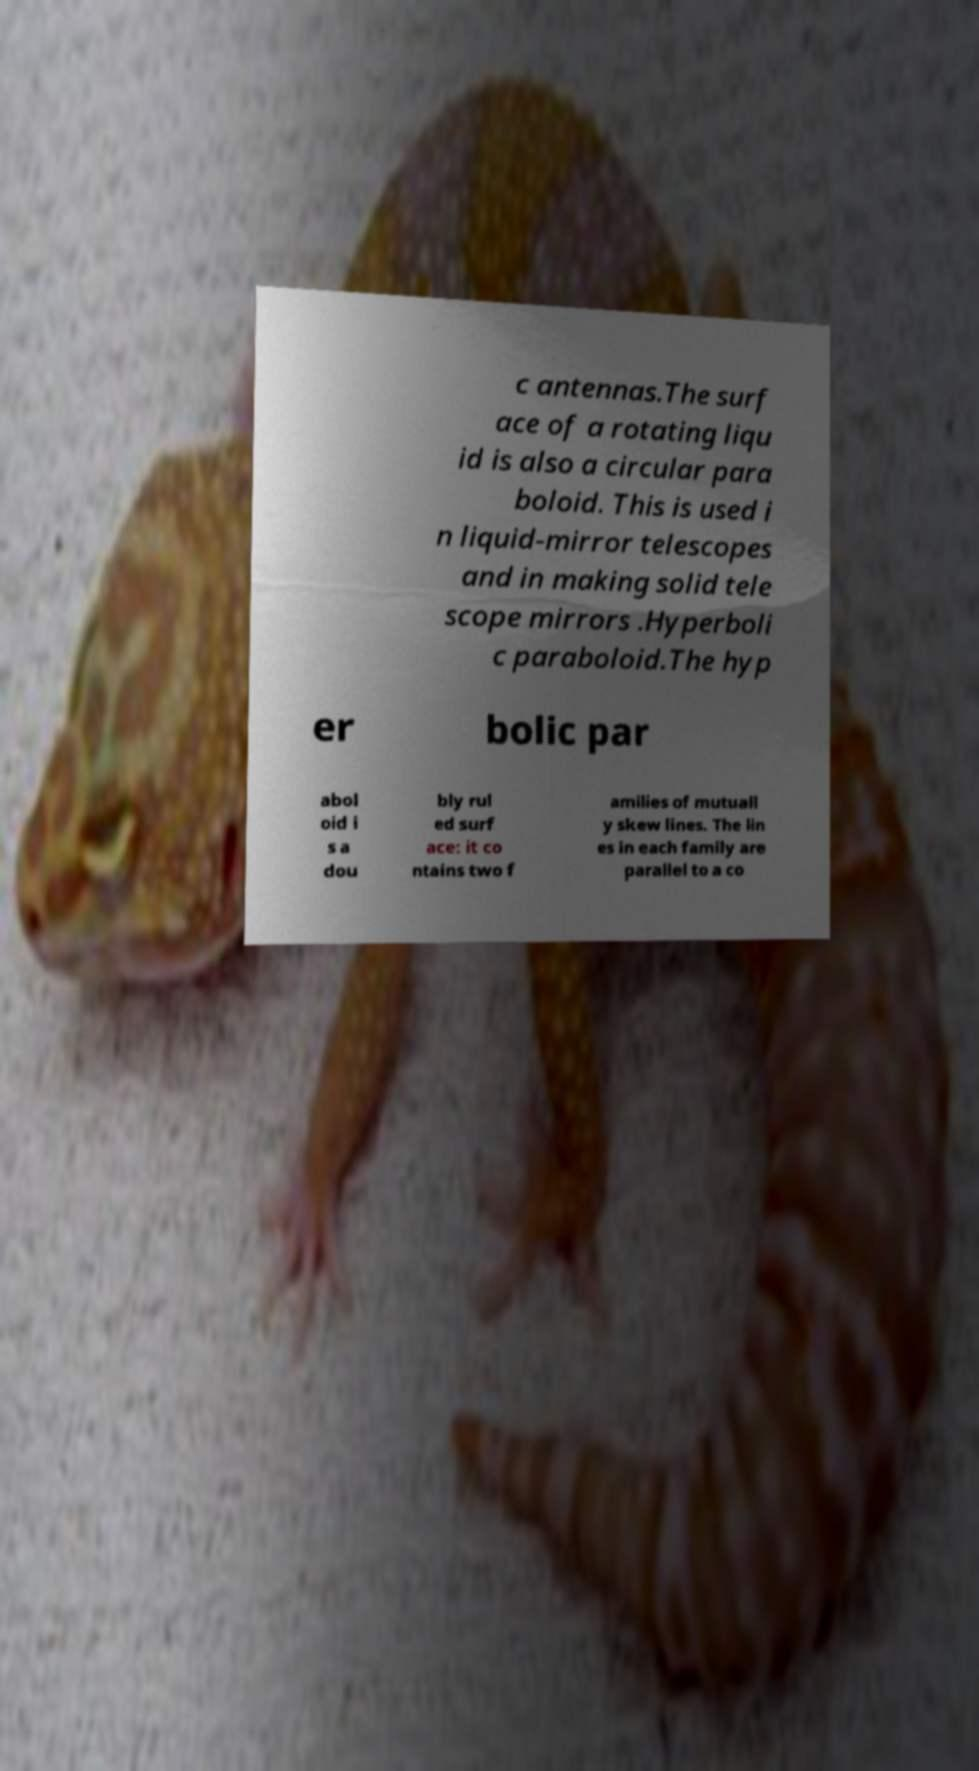There's text embedded in this image that I need extracted. Can you transcribe it verbatim? c antennas.The surf ace of a rotating liqu id is also a circular para boloid. This is used i n liquid-mirror telescopes and in making solid tele scope mirrors .Hyperboli c paraboloid.The hyp er bolic par abol oid i s a dou bly rul ed surf ace: it co ntains two f amilies of mutuall y skew lines. The lin es in each family are parallel to a co 